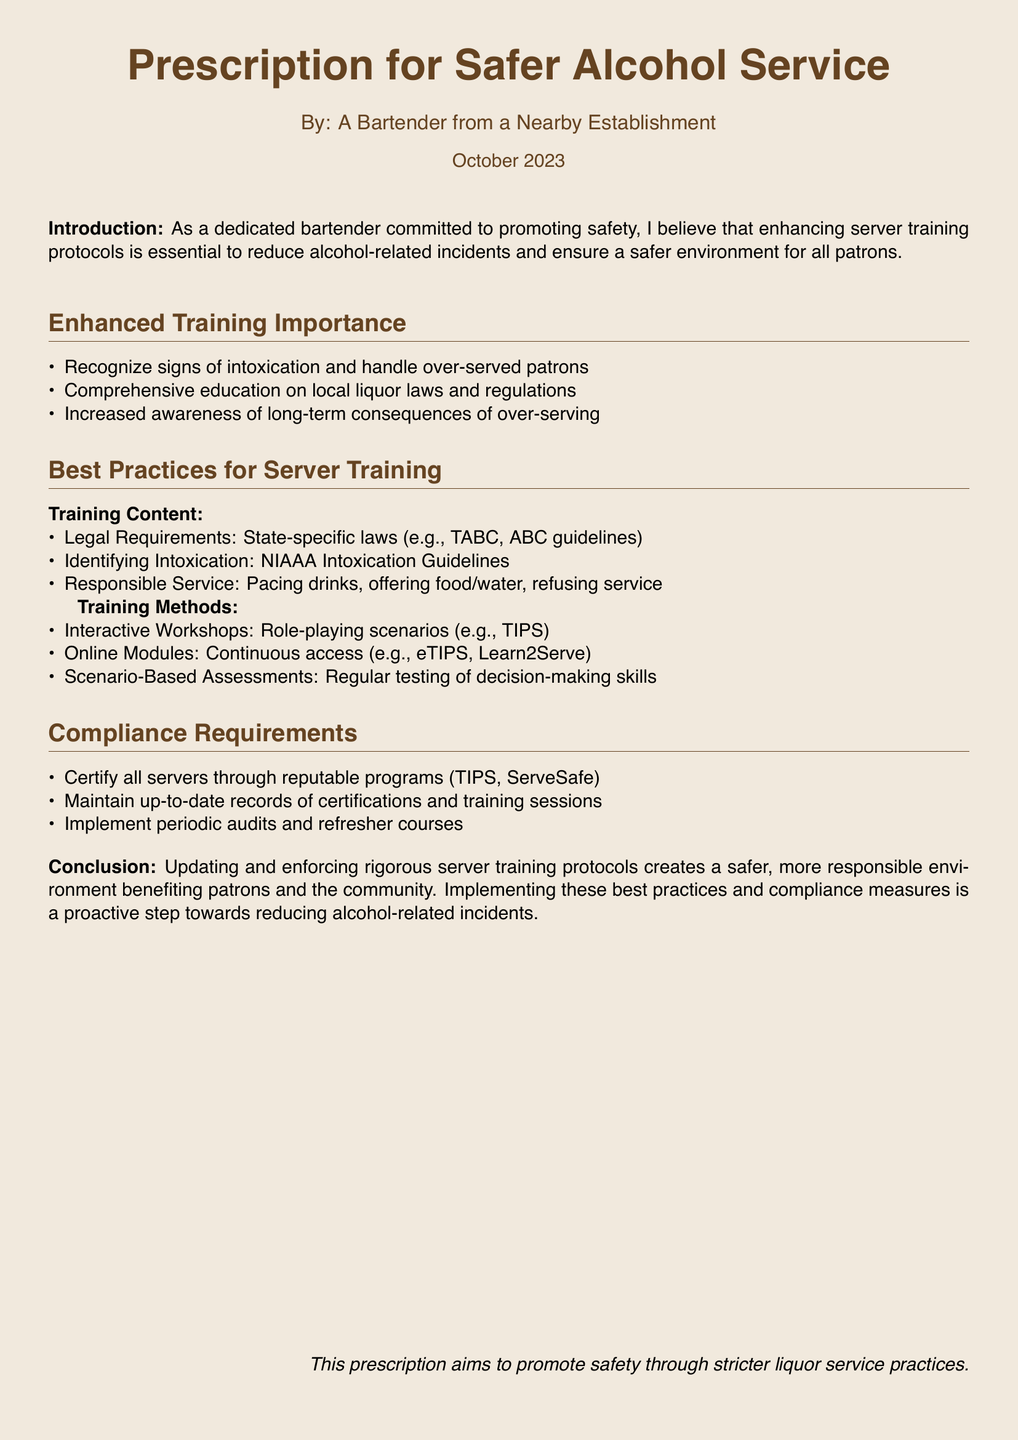What is the title of the document? The title is the main heading at the top of the document, which states the purpose and content of the prescription.
Answer: Prescription for Safer Alcohol Service Who authored the document? The author is indicated below the title, giving credit to the individual who created the prescription.
Answer: A Bartender from a Nearby Establishment What month and year was the document published? The publication date is mentioned at the bottom of the title block, indicating when the document was created.
Answer: October 2023 What training method involves role-playing scenarios? The training methods section outlines various methods for server training, including interactivity and practical applications.
Answer: Interactive Workshops What are servers required to be certified through? The compliance requirements dictate specific programs that servers must complete to ensure responsible service.
Answer: reputable programs (TIPS, ServeSafe) What is one reason for enhancing server training protocols? The introduction highlights the purpose behind improving training protocols and their expected outcomes.
Answer: reduce alcohol-related incidents How often should records of certifications be maintained? This is implied in the compliance requirements that mention maintaining up-to-date records.
Answer: regularly What guideline is referenced for identifying intoxication? This is found in the best practices section, indicating a specific set of guidelines servers should follow.
Answer: NIAAA Intoxication Guidelines What is the goal of updating server training protocols? The conclusion summarizes the intended outcome of implementing adequate server training practices.
Answer: create a safer, more responsible environment 